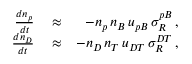<formula> <loc_0><loc_0><loc_500><loc_500>\begin{array} { r l r } { \frac { d n _ { p } } { d t } } & \approx } & { - n _ { p } \, n _ { B } \, u _ { p B } \, \sigma _ { R } ^ { p B } \, , } \\ { \frac { d n _ { D } } { d t } } & \approx } & { - n _ { D } \, n _ { T } \, u _ { D T } \, \sigma _ { R } ^ { D T } \, , } \end{array}</formula> 